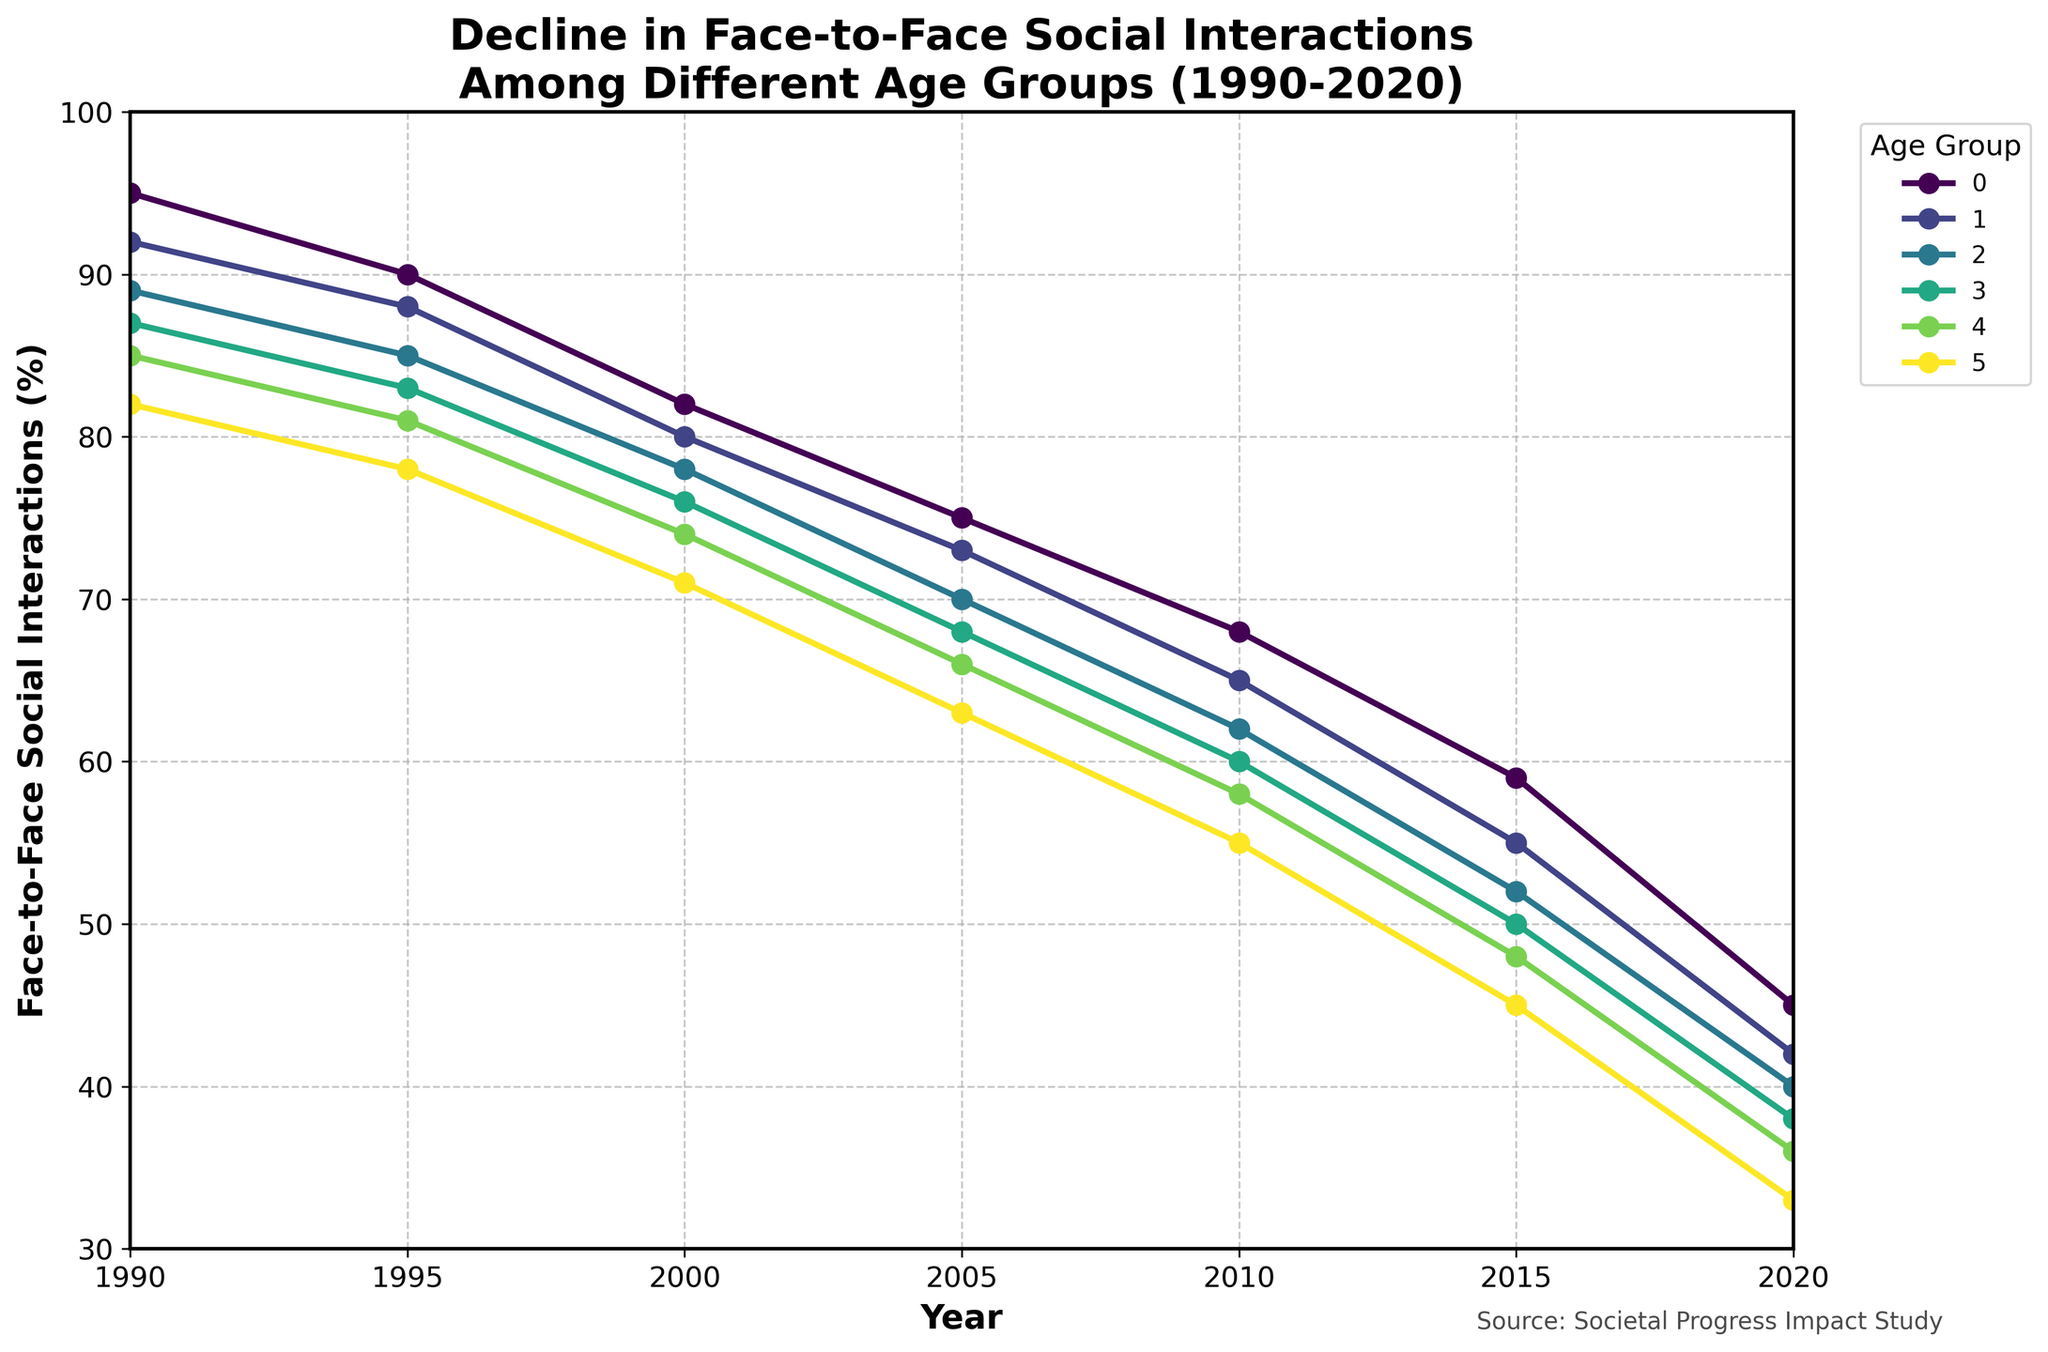What is the decline in face-to-face social interactions for the 18-24 age group from 1990 to 2020? To find the decline, subtract the value for 2020 from the value for 1990 for the 18-24 age group: (95 - 45)
Answer: 50 Which age group experienced the smallest decline in face-to-face social interactions from 1990 to 2020? Calculate the decline for each age group by subtracting the 2020 value from the 1990 value. The age group with the smallest difference is the 65+ group: 82 - 33 = 49
Answer: 65+ Which two age groups had their curves intersecting around the year 2005? To determine this, observe the trend lines closely around 2005. The 18-24 and 25-34 age groups intersect around this time
Answer: 18-24 and 25-34 What is the average face-to-face social interaction percentage for the 35-44 age group across all years shown? Add up all the values for the 35-44 age group and divide by the number of years (7): (89 + 85 + 78 + 70 + 62 + 52 + 40) / 7
Answer: 68 Does any age group have a year where the percentage of social interactions stayed the same as the previous year? Look for years where consecutive data points for an age group remain constant. No group shows this trend in the data provided
Answer: No Which age group showed the most significant percentage drop between 2010 and 2015? Subtract the 2015 value from the 2010 value for each age group, then find the age group with the largest difference. For the 18-24 age group: 68 - 59 = 9, which is the largest drop seen
Answer: 18-24 How does the trend of decline for the 55-64 age group compare with the general trend from 1990 to 2020? Analyze the slope of the decline for the 55-64 age group and compare it to the general downward trend observed across other age groups. The 55-64 group shows a steady decline similar to other age groups, moving from 85 to 36
Answer: Similar decline trend Which age group had the highest face-to-face social interactions percentage in 2000? By observing the data points for the year 2000, the age group 18-24 had the highest value at 82
Answer: 18-24 What is the median value of face-to-face social interactions for the age group 45-54 from 1990 to 2020? List the values in order and find the middle value. For 45-54: 38, 50, 60, 68, 76, 83, 87. The median is the fourth value (68)
Answer: 68 